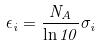Convert formula to latex. <formula><loc_0><loc_0><loc_500><loc_500>\epsilon _ { i } = \frac { N _ { A } } { \ln 1 0 } \sigma _ { i }</formula> 